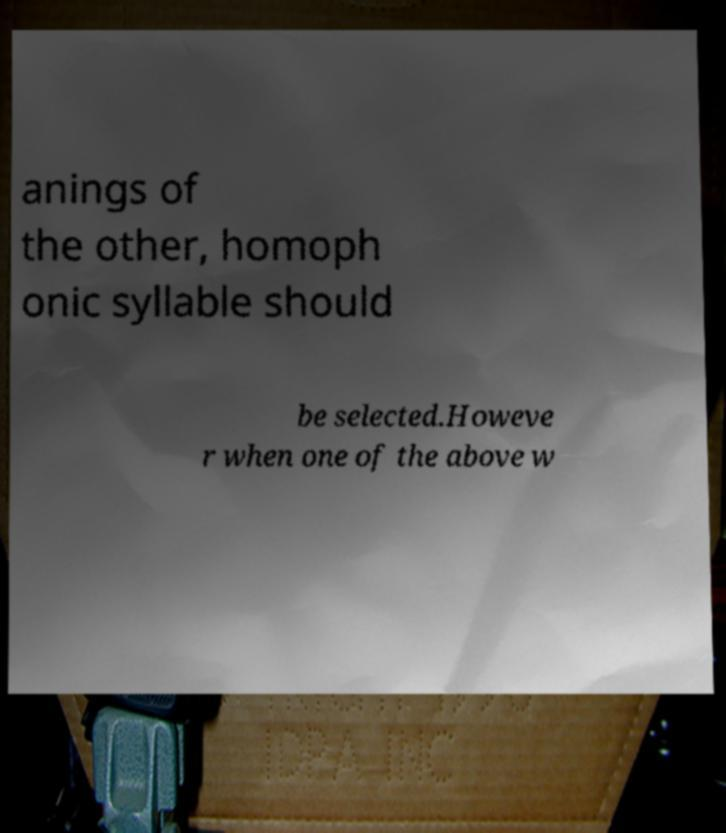For documentation purposes, I need the text within this image transcribed. Could you provide that? anings of the other, homoph onic syllable should be selected.Howeve r when one of the above w 